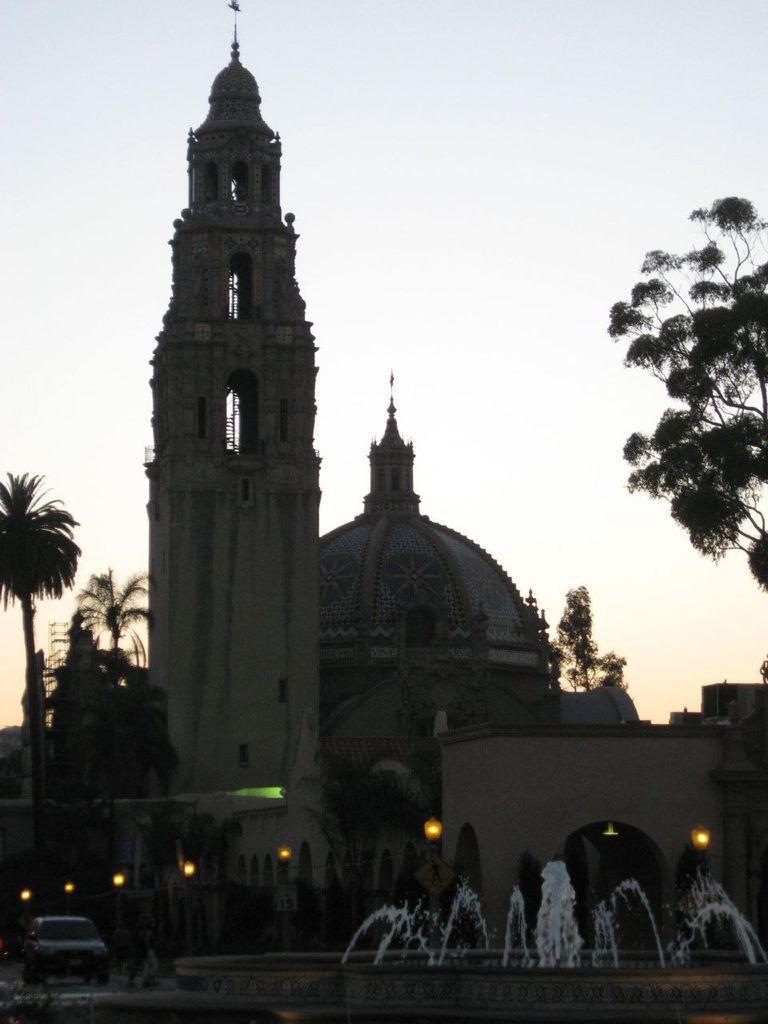In one or two sentences, can you explain what this image depicts? In the image there are buildings in the back with vehicles going in front of it and a water fall in the middle and above its sky, there are trees on either side. 